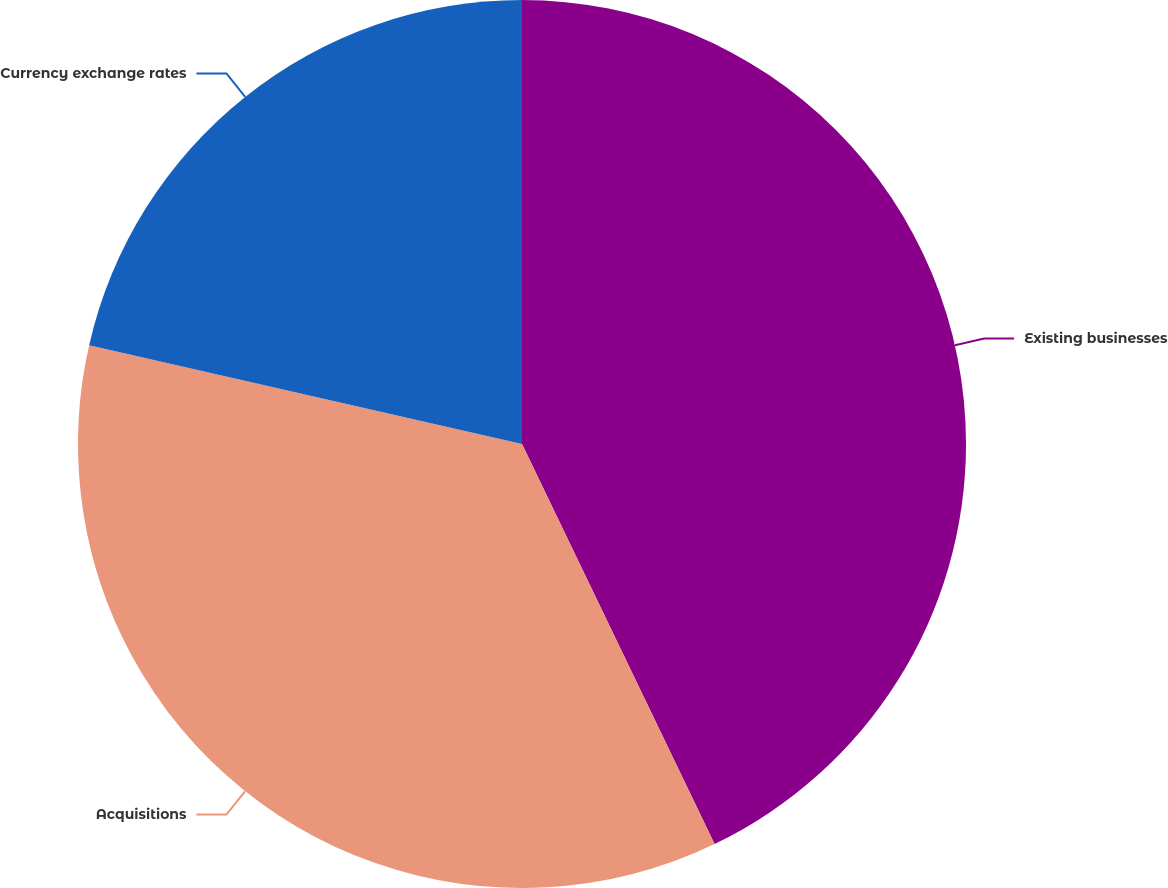Convert chart. <chart><loc_0><loc_0><loc_500><loc_500><pie_chart><fcel>Existing businesses<fcel>Acquisitions<fcel>Currency exchange rates<nl><fcel>42.86%<fcel>35.71%<fcel>21.43%<nl></chart> 